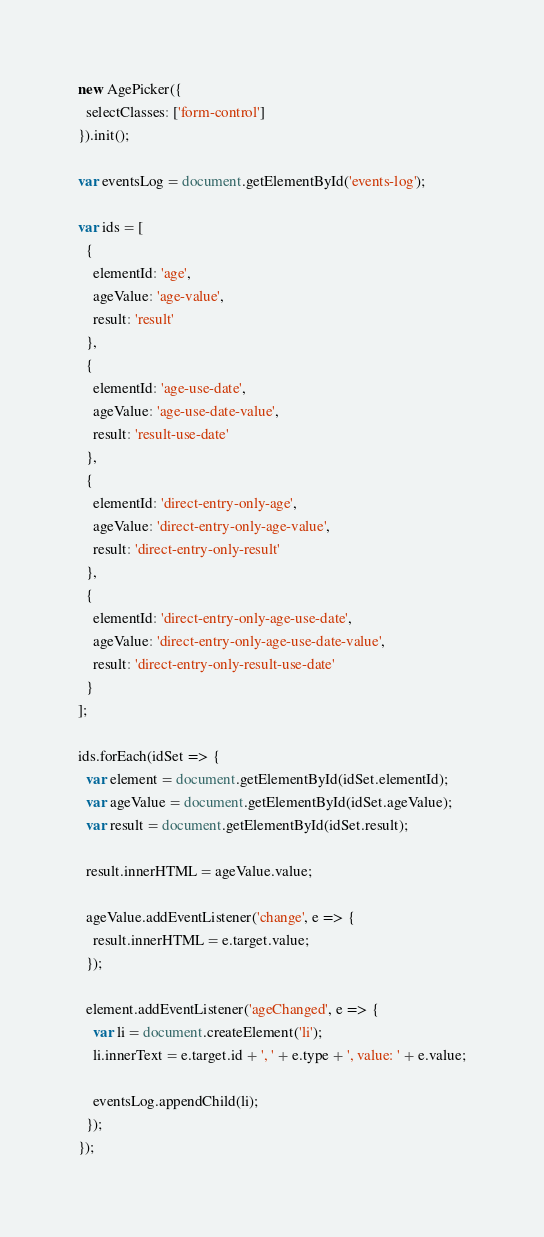<code> <loc_0><loc_0><loc_500><loc_500><_JavaScript_>new AgePicker({
  selectClasses: ['form-control']
}).init();

var eventsLog = document.getElementById('events-log');

var ids = [
  {
    elementId: 'age',
    ageValue: 'age-value',
    result: 'result'
  },
  {
    elementId: 'age-use-date',
    ageValue: 'age-use-date-value',
    result: 'result-use-date'
  },
  {
    elementId: 'direct-entry-only-age',
    ageValue: 'direct-entry-only-age-value',
    result: 'direct-entry-only-result'
  },
  {
    elementId: 'direct-entry-only-age-use-date',
    ageValue: 'direct-entry-only-age-use-date-value',
    result: 'direct-entry-only-result-use-date'
  }
];

ids.forEach(idSet => {
  var element = document.getElementById(idSet.elementId);
  var ageValue = document.getElementById(idSet.ageValue);
  var result = document.getElementById(idSet.result);

  result.innerHTML = ageValue.value;

  ageValue.addEventListener('change', e => {
    result.innerHTML = e.target.value;
  });

  element.addEventListener('ageChanged', e => {
    var li = document.createElement('li');
    li.innerText = e.target.id + ', ' + e.type + ', value: ' + e.value;

    eventsLog.appendChild(li);
  });
});
</code> 